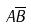<formula> <loc_0><loc_0><loc_500><loc_500>A \overline { B }</formula> 